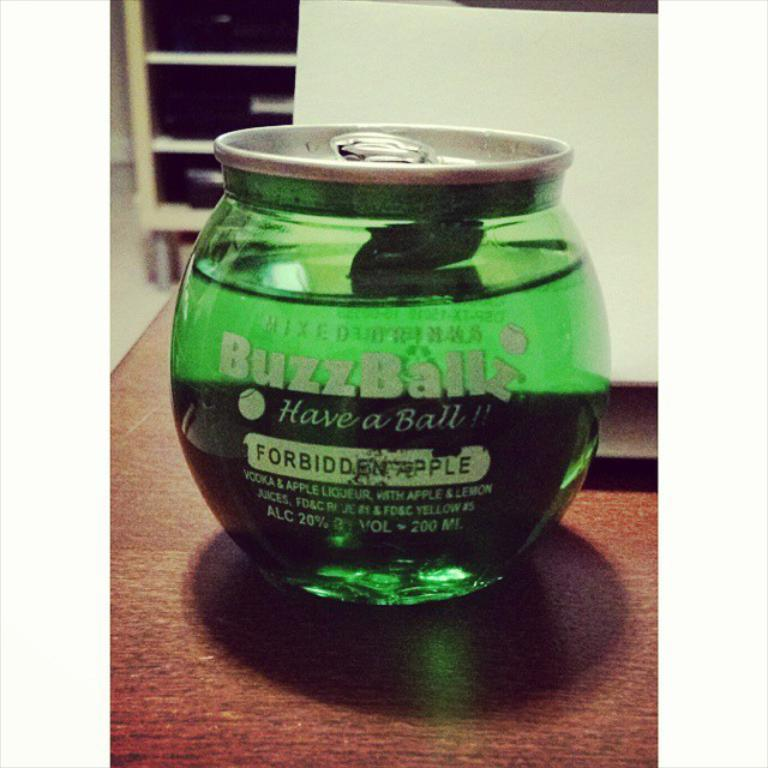Provide a one-sentence caption for the provided image. A bottle of Buzzball liqueur has 20% alcohol content. 